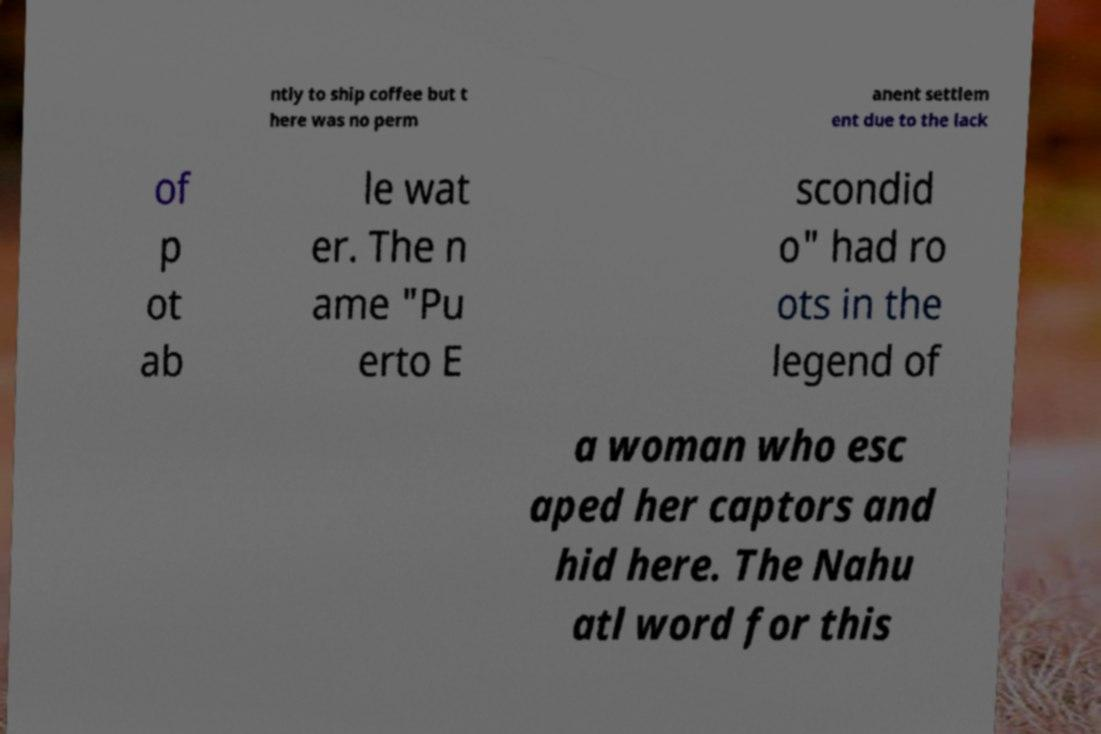I need the written content from this picture converted into text. Can you do that? ntly to ship coffee but t here was no perm anent settlem ent due to the lack of p ot ab le wat er. The n ame "Pu erto E scondid o" had ro ots in the legend of a woman who esc aped her captors and hid here. The Nahu atl word for this 